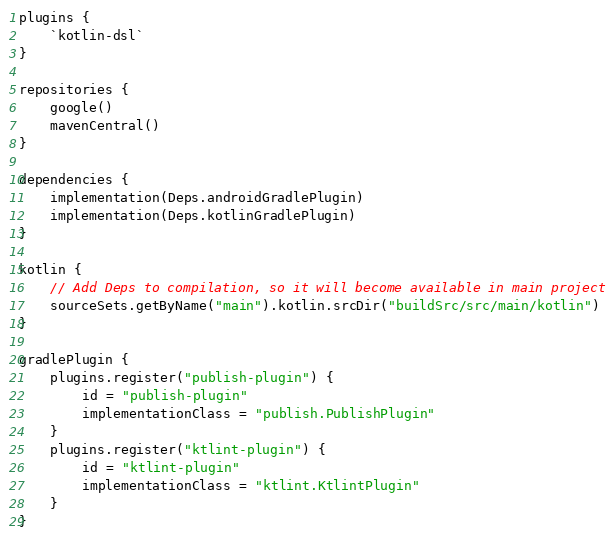<code> <loc_0><loc_0><loc_500><loc_500><_Kotlin_>plugins {
    `kotlin-dsl`
}

repositories {
    google()
    mavenCentral()
}

dependencies {
    implementation(Deps.androidGradlePlugin)
    implementation(Deps.kotlinGradlePlugin)
}

kotlin {
    // Add Deps to compilation, so it will become available in main project
    sourceSets.getByName("main").kotlin.srcDir("buildSrc/src/main/kotlin")
}

gradlePlugin {
    plugins.register("publish-plugin") {
        id = "publish-plugin"
        implementationClass = "publish.PublishPlugin"
    }
    plugins.register("ktlint-plugin") {
        id = "ktlint-plugin"
        implementationClass = "ktlint.KtlintPlugin"
    }
}
</code> 